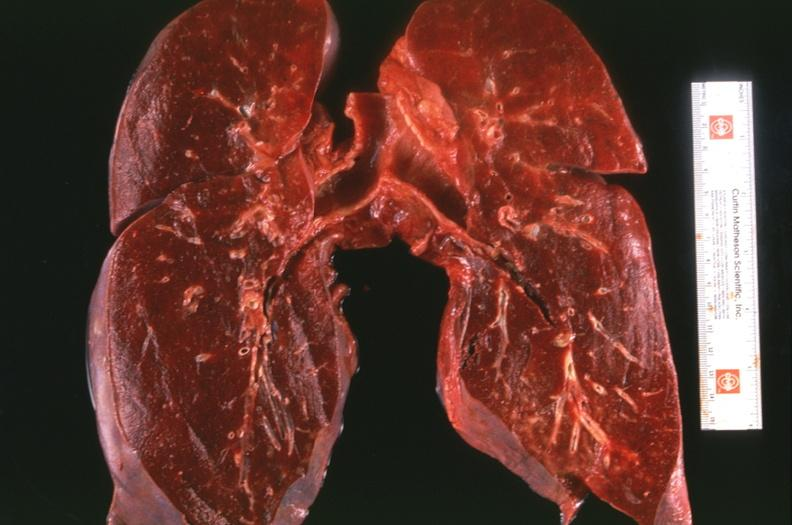where is this?
Answer the question using a single word or phrase. Lung 